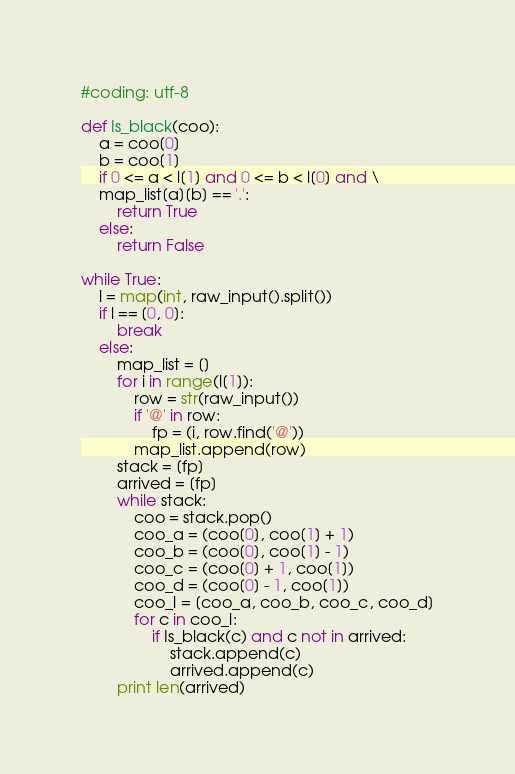<code> <loc_0><loc_0><loc_500><loc_500><_Python_>#coding: utf-8

def Is_black(coo):
    a = coo[0]
    b = coo[1]
    if 0 <= a < l[1] and 0 <= b < l[0] and \
    map_list[a][b] == '.':
        return True
    else:
        return False

while True:
    l = map(int, raw_input().split())
    if l == [0, 0]:
        break
    else:
        map_list = []
        for i in range(l[1]):
            row = str(raw_input())
            if '@' in row:
                fp = (i, row.find('@'))
            map_list.append(row)
        stack = [fp]
        arrived = [fp]
        while stack:
            coo = stack.pop()
            coo_a = (coo[0], coo[1] + 1)
            coo_b = (coo[0], coo[1] - 1)
            coo_c = (coo[0] + 1, coo[1])
            coo_d = (coo[0] - 1, coo[1])
            coo_l = [coo_a, coo_b, coo_c, coo_d]
            for c in coo_l:
                if Is_black(c) and c not in arrived:
                    stack.append(c)
                    arrived.append(c)
        print len(arrived)</code> 